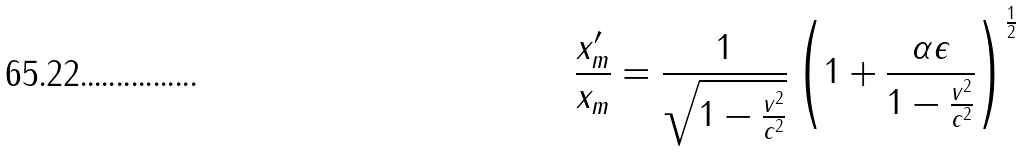<formula> <loc_0><loc_0><loc_500><loc_500>\frac { x ^ { \prime } _ { m } } { x _ { m } } = \frac { 1 } { \sqrt { 1 - \frac { v ^ { 2 } } { c ^ { 2 } } } } \left ( 1 + \frac { \alpha \epsilon } { 1 - \frac { v ^ { 2 } } { c ^ { 2 } } } \right ) ^ { \frac { 1 } { 2 } }</formula> 